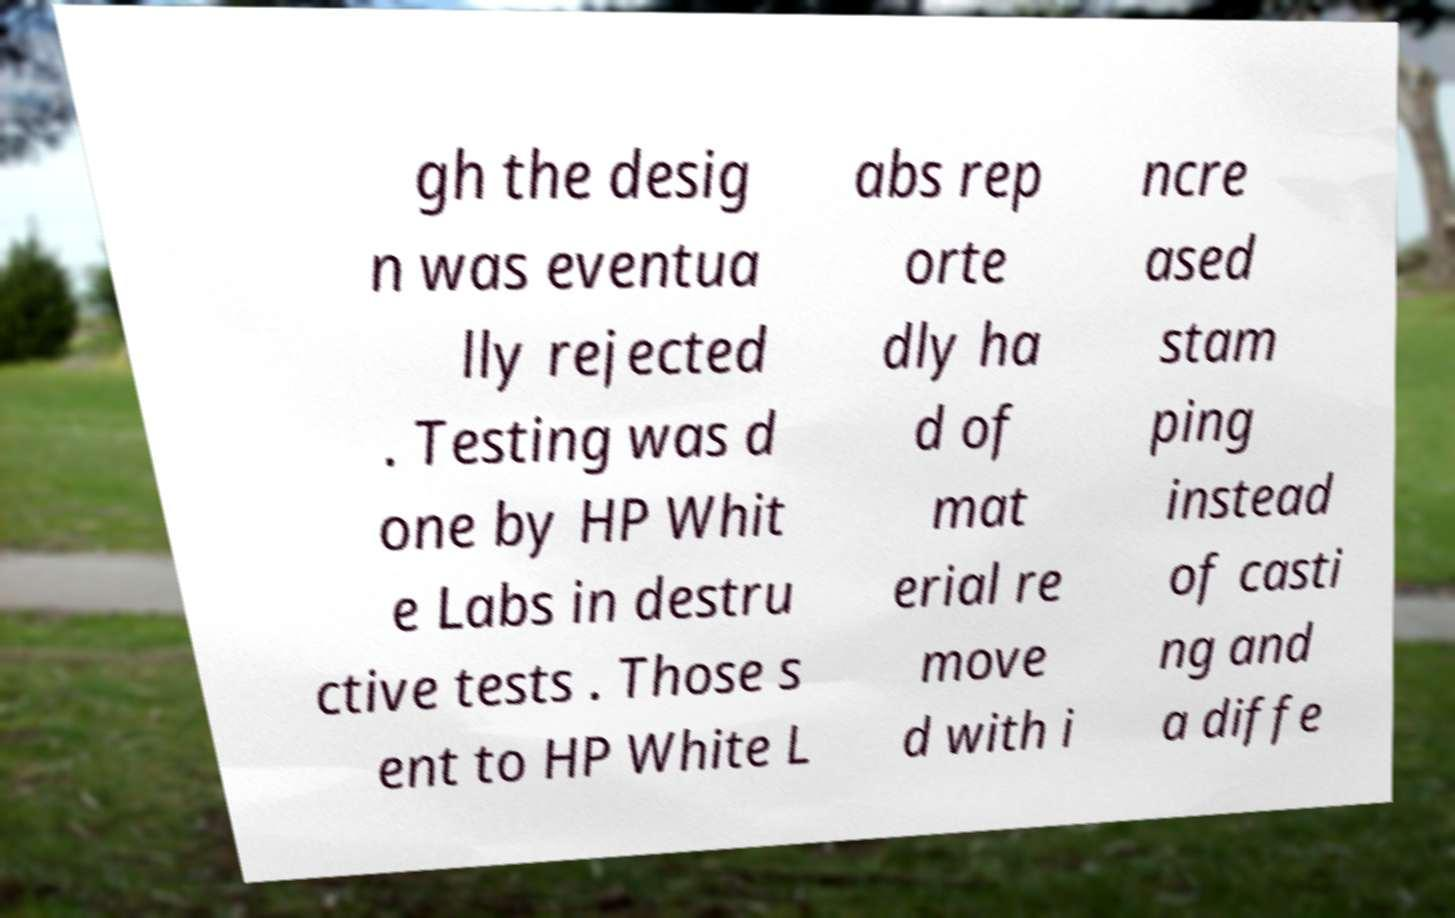Please identify and transcribe the text found in this image. gh the desig n was eventua lly rejected . Testing was d one by HP Whit e Labs in destru ctive tests . Those s ent to HP White L abs rep orte dly ha d of mat erial re move d with i ncre ased stam ping instead of casti ng and a diffe 